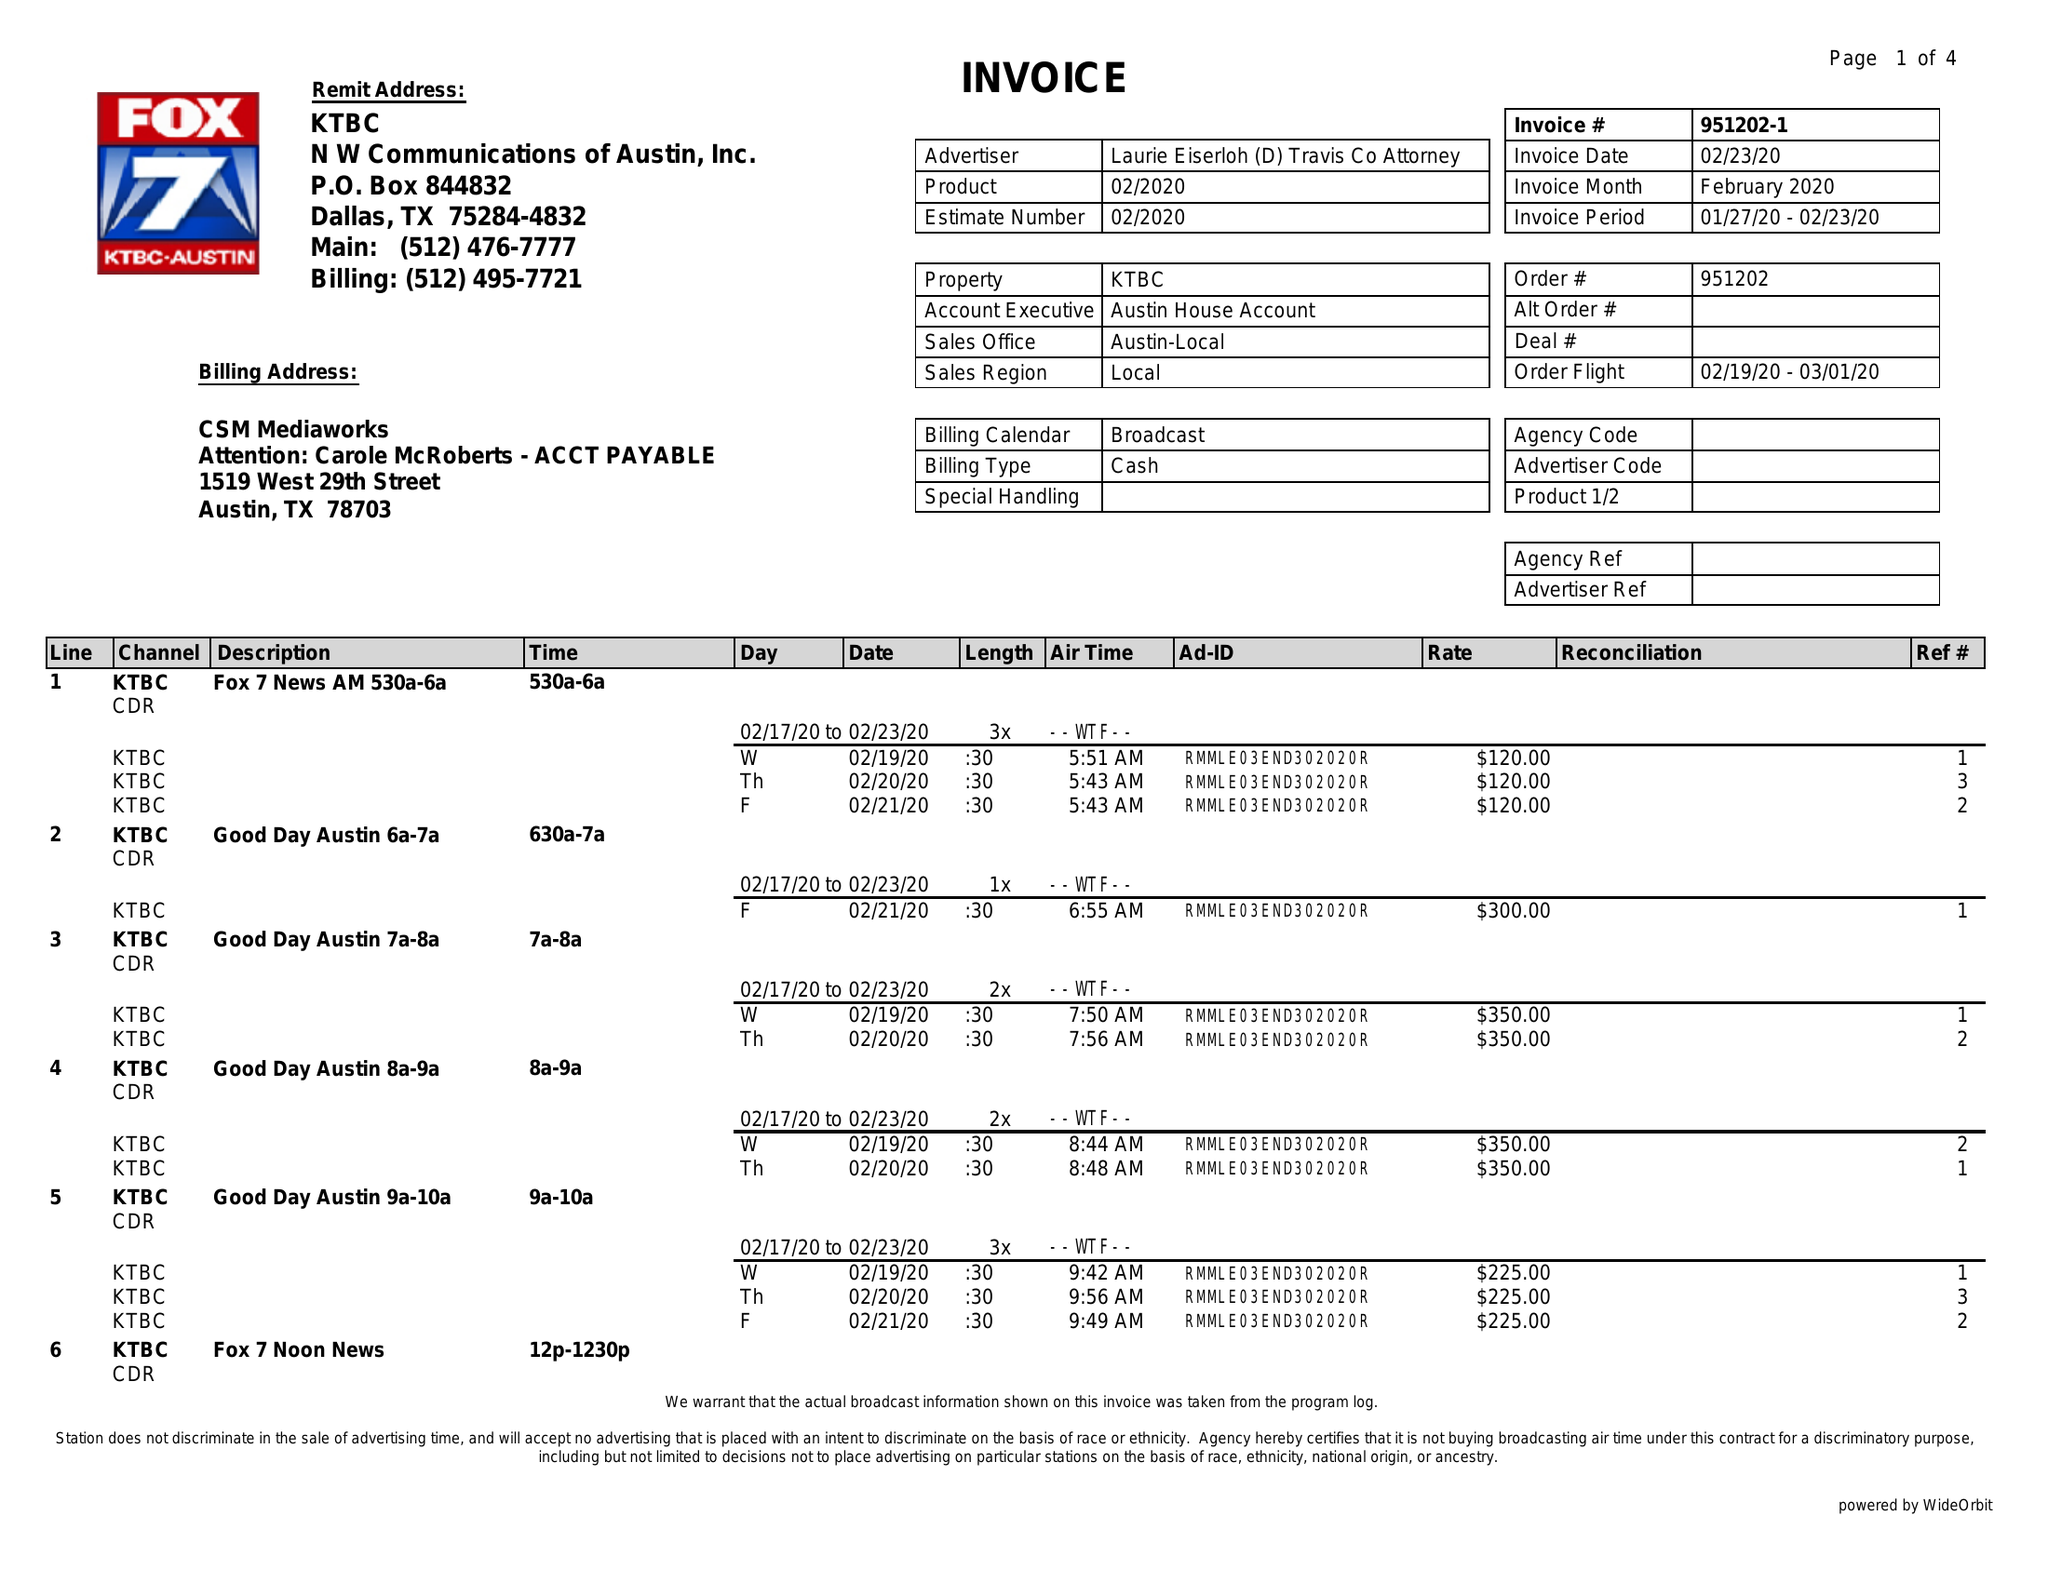What is the value for the flight_to?
Answer the question using a single word or phrase. 03/01/20 